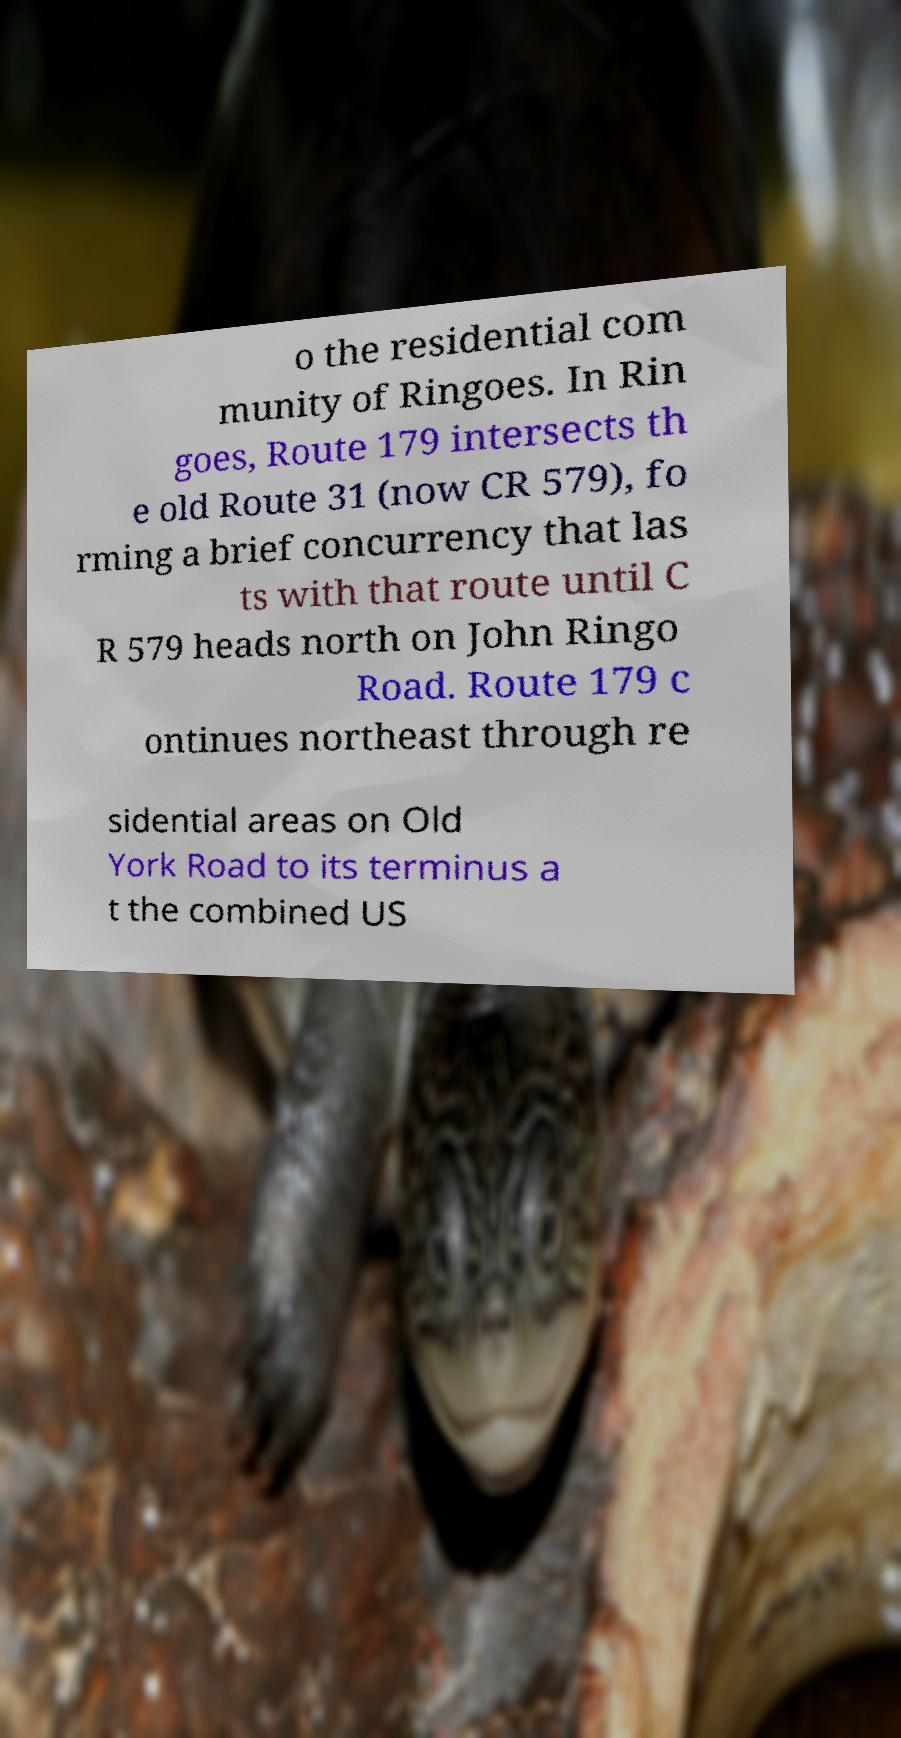Could you extract and type out the text from this image? o the residential com munity of Ringoes. In Rin goes, Route 179 intersects th e old Route 31 (now CR 579), fo rming a brief concurrency that las ts with that route until C R 579 heads north on John Ringo Road. Route 179 c ontinues northeast through re sidential areas on Old York Road to its terminus a t the combined US 